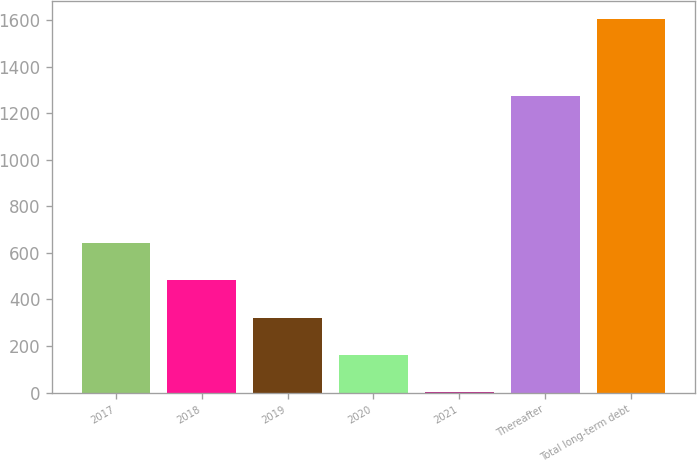Convert chart to OTSL. <chart><loc_0><loc_0><loc_500><loc_500><bar_chart><fcel>2017<fcel>2018<fcel>2019<fcel>2020<fcel>2021<fcel>Thereafter<fcel>Total long-term debt<nl><fcel>642.3<fcel>481.91<fcel>321.52<fcel>161.13<fcel>0.74<fcel>1276.4<fcel>1604.6<nl></chart> 